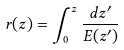<formula> <loc_0><loc_0><loc_500><loc_500>r ( z ) = \int _ { 0 } ^ { z } { \frac { d z ^ { \prime } } { E ( z ^ { \prime } ) } }</formula> 